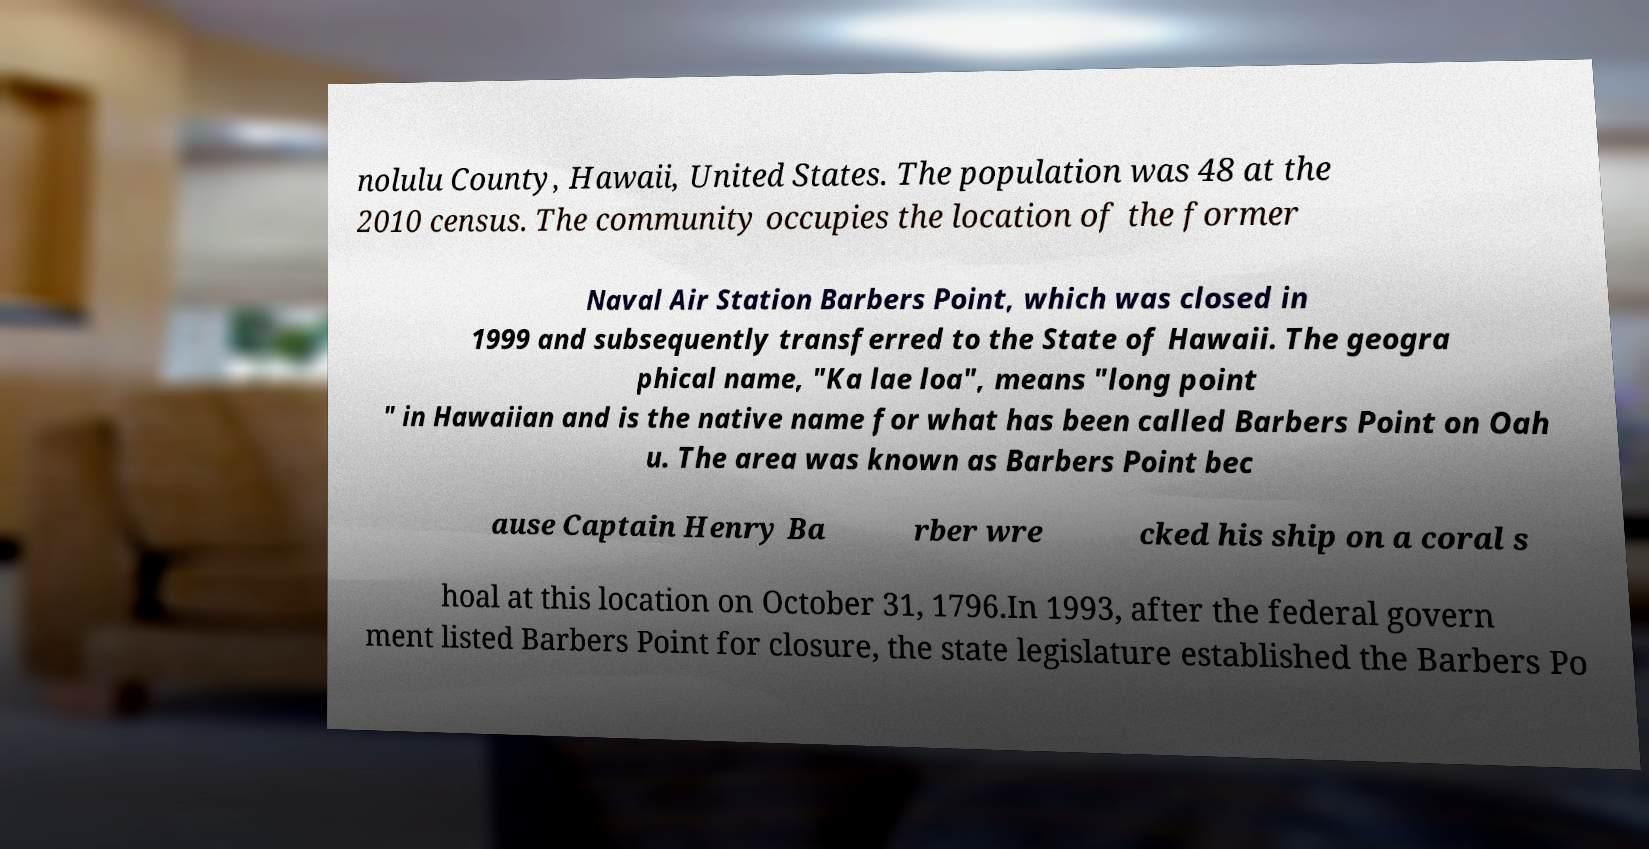Could you assist in decoding the text presented in this image and type it out clearly? nolulu County, Hawaii, United States. The population was 48 at the 2010 census. The community occupies the location of the former Naval Air Station Barbers Point, which was closed in 1999 and subsequently transferred to the State of Hawaii. The geogra phical name, "Ka lae loa", means "long point " in Hawaiian and is the native name for what has been called Barbers Point on Oah u. The area was known as Barbers Point bec ause Captain Henry Ba rber wre cked his ship on a coral s hoal at this location on October 31, 1796.In 1993, after the federal govern ment listed Barbers Point for closure, the state legislature established the Barbers Po 